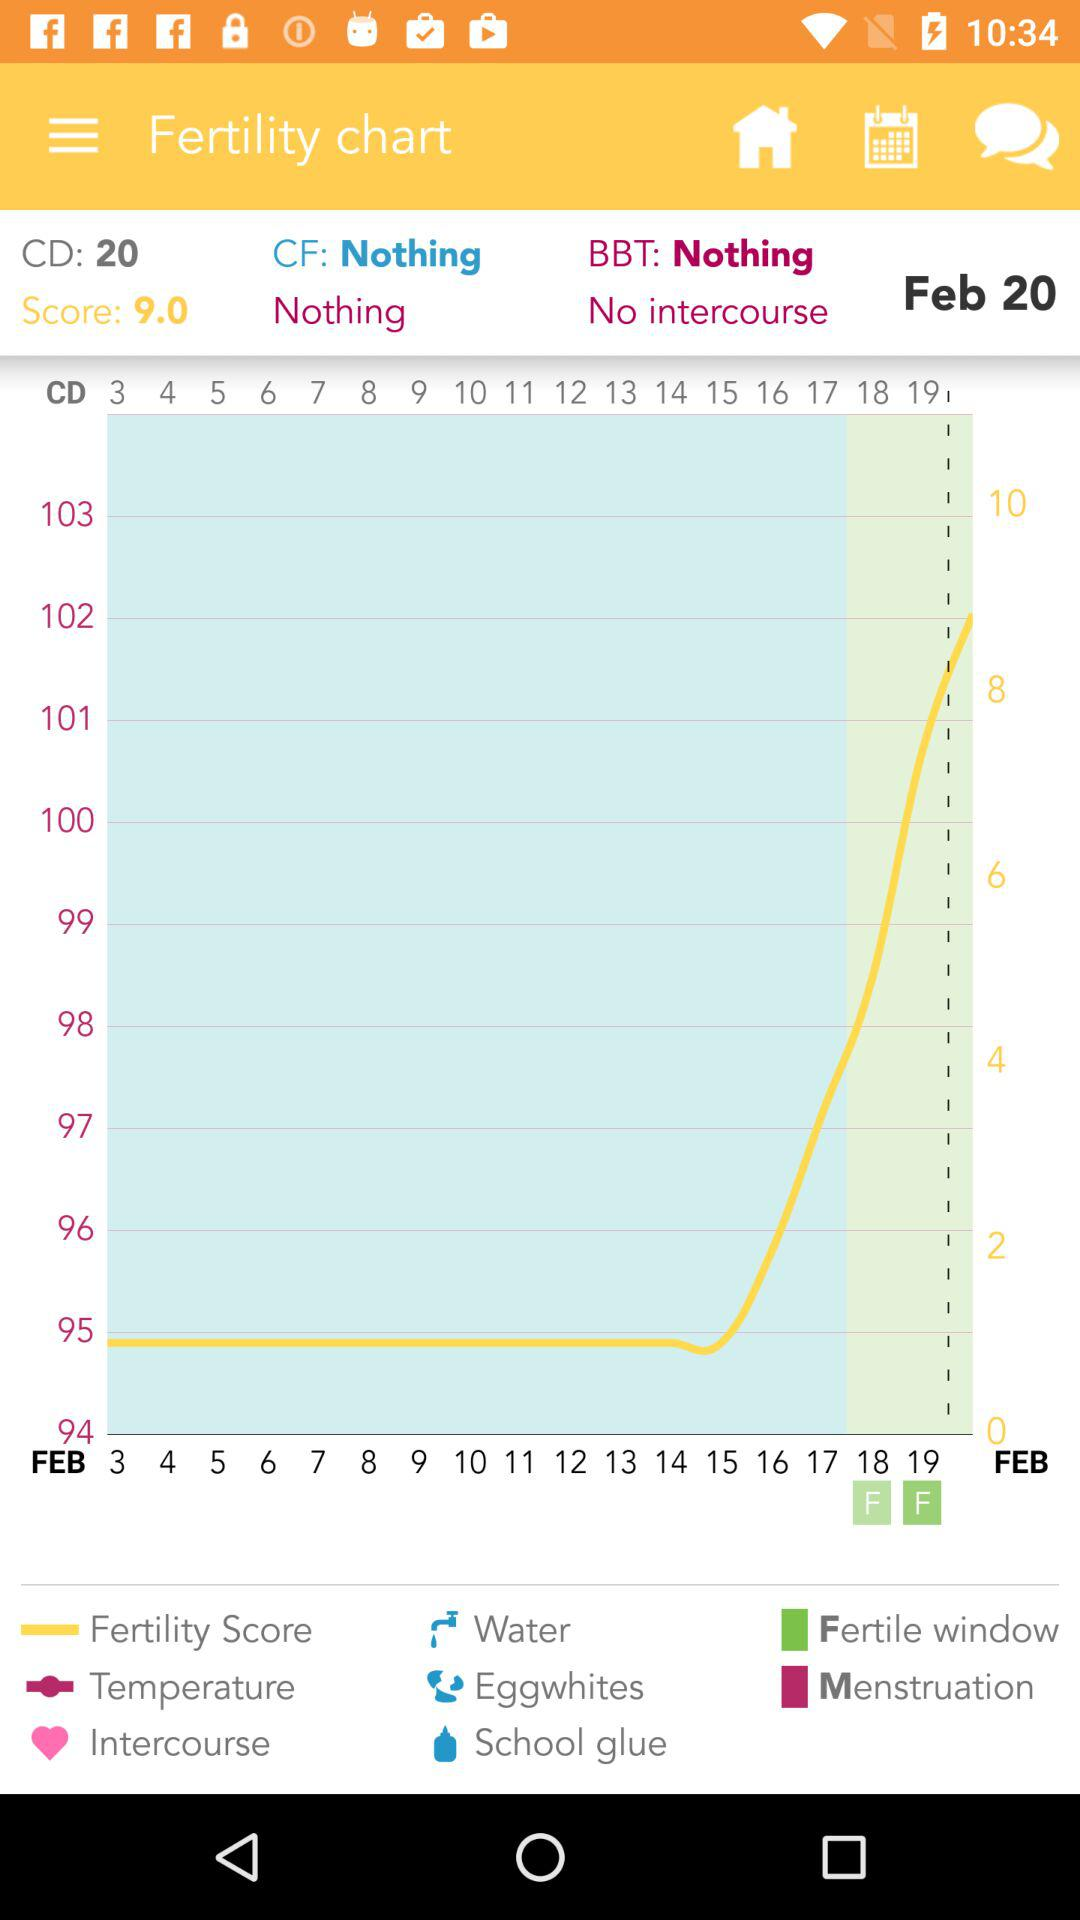What month is it? The month is February. 